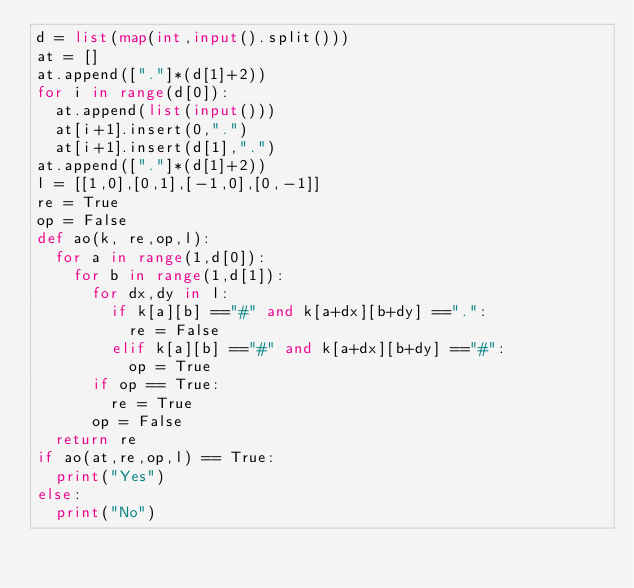Convert code to text. <code><loc_0><loc_0><loc_500><loc_500><_Python_>d = list(map(int,input().split()))
at = []
at.append(["."]*(d[1]+2))
for i in range(d[0]):
  at.append(list(input()))
  at[i+1].insert(0,".")
  at[i+1].insert(d[1],".")
at.append(["."]*(d[1]+2))
l = [[1,0],[0,1],[-1,0],[0,-1]]
re = True
op = False
def ao(k, re,op,l):
  for a in range(1,d[0]):
    for b in range(1,d[1]):
      for dx,dy in l:
        if k[a][b] =="#" and k[a+dx][b+dy] ==".":
          re = False
        elif k[a][b] =="#" and k[a+dx][b+dy] =="#":
          op = True
      if op == True:
        re = True
      op = False
  return re
if ao(at,re,op,l) == True:
  print("Yes")
else:
  print("No")</code> 